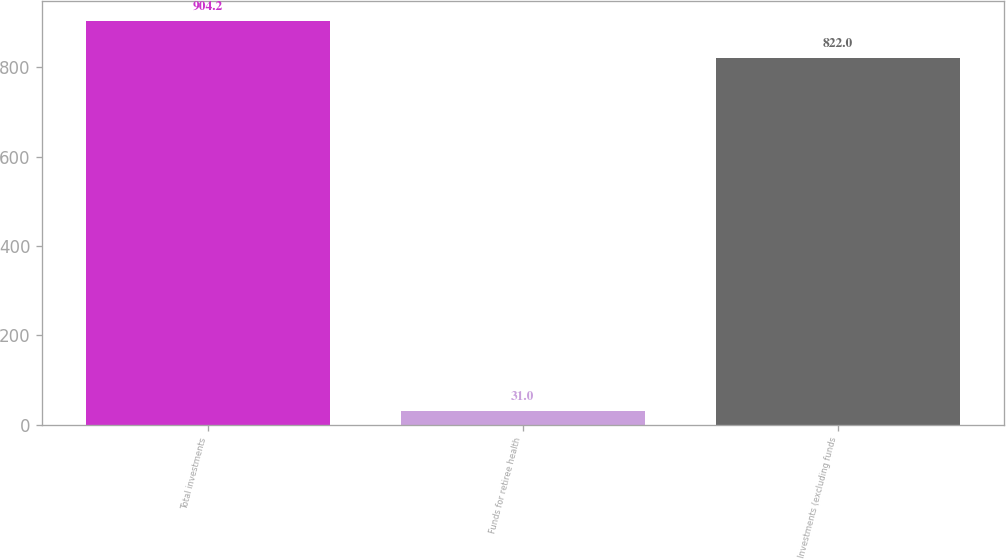Convert chart to OTSL. <chart><loc_0><loc_0><loc_500><loc_500><bar_chart><fcel>Total investments<fcel>Funds for retiree health<fcel>Investments (excluding funds<nl><fcel>904.2<fcel>31<fcel>822<nl></chart> 